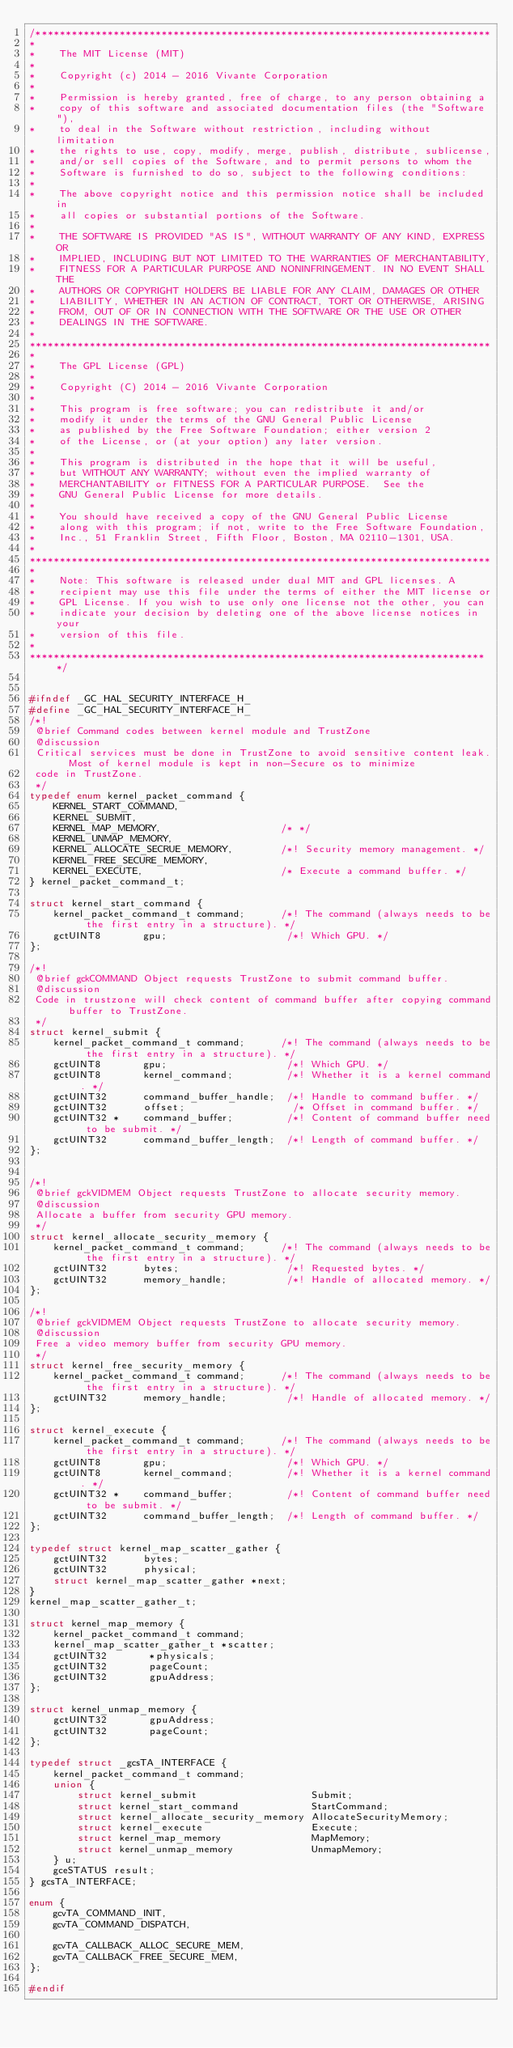Convert code to text. <code><loc_0><loc_0><loc_500><loc_500><_C_>/****************************************************************************
*
*    The MIT License (MIT)
*
*    Copyright (c) 2014 - 2016 Vivante Corporation
*
*    Permission is hereby granted, free of charge, to any person obtaining a
*    copy of this software and associated documentation files (the "Software"),
*    to deal in the Software without restriction, including without limitation
*    the rights to use, copy, modify, merge, publish, distribute, sublicense,
*    and/or sell copies of the Software, and to permit persons to whom the
*    Software is furnished to do so, subject to the following conditions:
*
*    The above copyright notice and this permission notice shall be included in
*    all copies or substantial portions of the Software.
*
*    THE SOFTWARE IS PROVIDED "AS IS", WITHOUT WARRANTY OF ANY KIND, EXPRESS OR
*    IMPLIED, INCLUDING BUT NOT LIMITED TO THE WARRANTIES OF MERCHANTABILITY,
*    FITNESS FOR A PARTICULAR PURPOSE AND NONINFRINGEMENT. IN NO EVENT SHALL THE
*    AUTHORS OR COPYRIGHT HOLDERS BE LIABLE FOR ANY CLAIM, DAMAGES OR OTHER
*    LIABILITY, WHETHER IN AN ACTION OF CONTRACT, TORT OR OTHERWISE, ARISING
*    FROM, OUT OF OR IN CONNECTION WITH THE SOFTWARE OR THE USE OR OTHER
*    DEALINGS IN THE SOFTWARE.
*
*****************************************************************************
*
*    The GPL License (GPL)
*
*    Copyright (C) 2014 - 2016 Vivante Corporation
*
*    This program is free software; you can redistribute it and/or
*    modify it under the terms of the GNU General Public License
*    as published by the Free Software Foundation; either version 2
*    of the License, or (at your option) any later version.
*
*    This program is distributed in the hope that it will be useful,
*    but WITHOUT ANY WARRANTY; without even the implied warranty of
*    MERCHANTABILITY or FITNESS FOR A PARTICULAR PURPOSE.  See the
*    GNU General Public License for more details.
*
*    You should have received a copy of the GNU General Public License
*    along with this program; if not, write to the Free Software Foundation,
*    Inc., 51 Franklin Street, Fifth Floor, Boston, MA 02110-1301, USA.
*
*****************************************************************************
*
*    Note: This software is released under dual MIT and GPL licenses. A
*    recipient may use this file under the terms of either the MIT license or
*    GPL License. If you wish to use only one license not the other, you can
*    indicate your decision by deleting one of the above license notices in your
*    version of this file.
*
*****************************************************************************/


#ifndef _GC_HAL_SECURITY_INTERFACE_H_
#define _GC_HAL_SECURITY_INTERFACE_H_
/*!
 @brief Command codes between kernel module and TrustZone
 @discussion
 Critical services must be done in TrustZone to avoid sensitive content leak. Most of kernel module is kept in non-Secure os to minimize
 code in TrustZone.
 */
typedef enum kernel_packet_command {
    KERNEL_START_COMMAND,
    KERNEL_SUBMIT,
    KERNEL_MAP_MEMORY,                    /* */
    KERNEL_UNMAP_MEMORY,
    KERNEL_ALLOCATE_SECRUE_MEMORY,        /*! Security memory management. */
    KERNEL_FREE_SECURE_MEMORY,
    KERNEL_EXECUTE,                       /* Execute a command buffer. */
} kernel_packet_command_t;

struct kernel_start_command {
    kernel_packet_command_t command;      /*! The command (always needs to be the first entry in a structure). */
    gctUINT8       gpu;                    /*! Which GPU. */
};

/*!
 @brief gckCOMMAND Object requests TrustZone to submit command buffer.
 @discussion
 Code in trustzone will check content of command buffer after copying command buffer to TrustZone.
 */
struct kernel_submit {
    kernel_packet_command_t command;      /*! The command (always needs to be the first entry in a structure). */
    gctUINT8       gpu;                    /*! Which GPU. */
    gctUINT8       kernel_command;         /*! Whether it is a kernel command. */
    gctUINT32      command_buffer_handle;  /*! Handle to command buffer. */
    gctUINT32      offset;                  /* Offset in command buffer. */
    gctUINT32 *    command_buffer;         /*! Content of command buffer need to be submit. */
    gctUINT32      command_buffer_length;  /*! Length of command buffer. */
};


/*!
 @brief gckVIDMEM Object requests TrustZone to allocate security memory.
 @discussion
 Allocate a buffer from security GPU memory.
 */
struct kernel_allocate_security_memory {
    kernel_packet_command_t command;      /*! The command (always needs to be the first entry in a structure). */
    gctUINT32      bytes;                  /*! Requested bytes. */
    gctUINT32      memory_handle;          /*! Handle of allocated memory. */
};

/*!
 @brief gckVIDMEM Object requests TrustZone to allocate security memory.
 @discussion
 Free a video memory buffer from security GPU memory.
 */
struct kernel_free_security_memory {
    kernel_packet_command_t command;      /*! The command (always needs to be the first entry in a structure). */
    gctUINT32      memory_handle;          /*! Handle of allocated memory. */
};

struct kernel_execute {
    kernel_packet_command_t command;      /*! The command (always needs to be the first entry in a structure). */
    gctUINT8       gpu;                    /*! Which GPU. */
    gctUINT8       kernel_command;         /*! Whether it is a kernel command. */
    gctUINT32 *    command_buffer;         /*! Content of command buffer need to be submit. */
    gctUINT32      command_buffer_length;  /*! Length of command buffer. */
};

typedef struct kernel_map_scatter_gather {
    gctUINT32      bytes;
    gctUINT32      physical;
    struct kernel_map_scatter_gather *next;
}
kernel_map_scatter_gather_t;

struct kernel_map_memory {
    kernel_packet_command_t command;
    kernel_map_scatter_gather_t *scatter;
    gctUINT32       *physicals;
    gctUINT32       pageCount;
    gctUINT32       gpuAddress;
};

struct kernel_unmap_memory {
    gctUINT32       gpuAddress;
    gctUINT32       pageCount;
};

typedef struct _gcsTA_INTERFACE {
    kernel_packet_command_t command;
    union {
        struct kernel_submit                   Submit;
        struct kernel_start_command            StartCommand;
        struct kernel_allocate_security_memory AllocateSecurityMemory;
        struct kernel_execute                  Execute;
        struct kernel_map_memory               MapMemory;
        struct kernel_unmap_memory             UnmapMemory;
    } u;
    gceSTATUS result;
} gcsTA_INTERFACE;

enum {
    gcvTA_COMMAND_INIT,
    gcvTA_COMMAND_DISPATCH,

    gcvTA_CALLBACK_ALLOC_SECURE_MEM,
    gcvTA_CALLBACK_FREE_SECURE_MEM,
};

#endif
</code> 